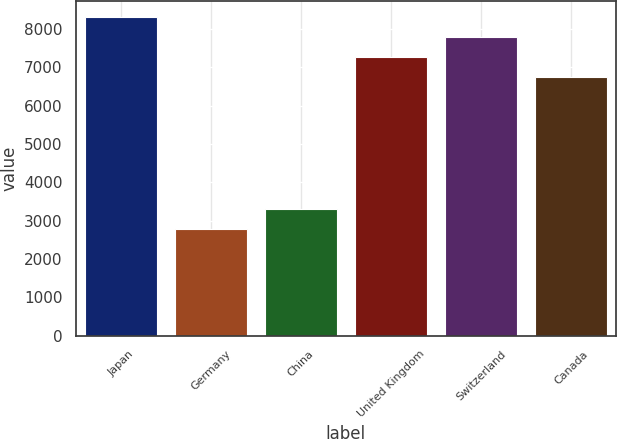Convert chart to OTSL. <chart><loc_0><loc_0><loc_500><loc_500><bar_chart><fcel>Japan<fcel>Germany<fcel>China<fcel>United Kingdom<fcel>Switzerland<fcel>Canada<nl><fcel>8307<fcel>2782<fcel>3304<fcel>7263<fcel>7785<fcel>6741<nl></chart> 